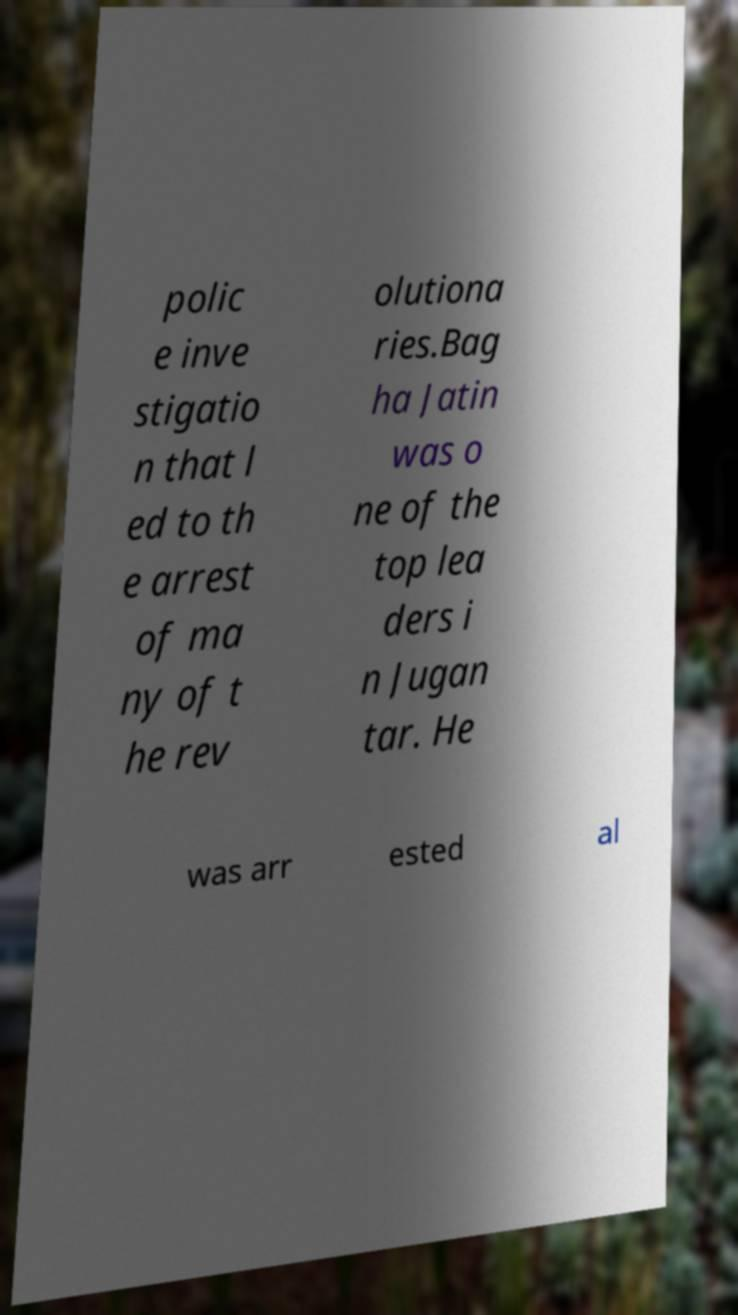Can you accurately transcribe the text from the provided image for me? polic e inve stigatio n that l ed to th e arrest of ma ny of t he rev olutiona ries.Bag ha Jatin was o ne of the top lea ders i n Jugan tar. He was arr ested al 